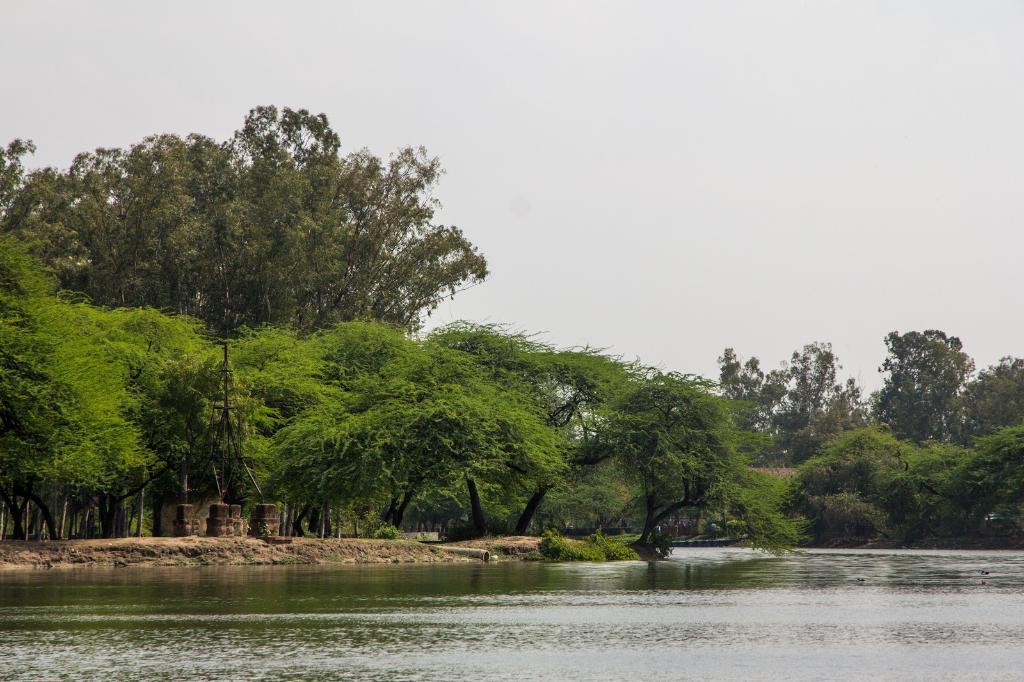Please provide a concise description of this image. In this image at the bottom there is a river and in the background there are some trees and sand, and at the top of the image there is sky. 